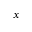Convert formula to latex. <formula><loc_0><loc_0><loc_500><loc_500>x</formula> 